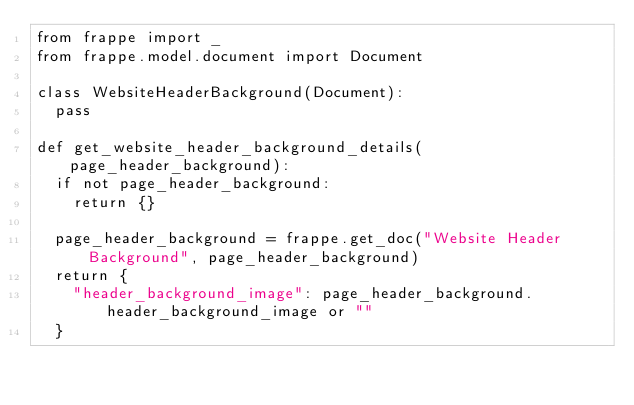Convert code to text. <code><loc_0><loc_0><loc_500><loc_500><_Python_>from frappe import _
from frappe.model.document import Document

class WebsiteHeaderBackground(Document):
	pass

def get_website_header_background_details(page_header_background):
	if not page_header_background:
		return {}
		
	page_header_background = frappe.get_doc("Website Header Background", page_header_background)
	return {
		"header_background_image": page_header_background.header_background_image or ""
	}</code> 